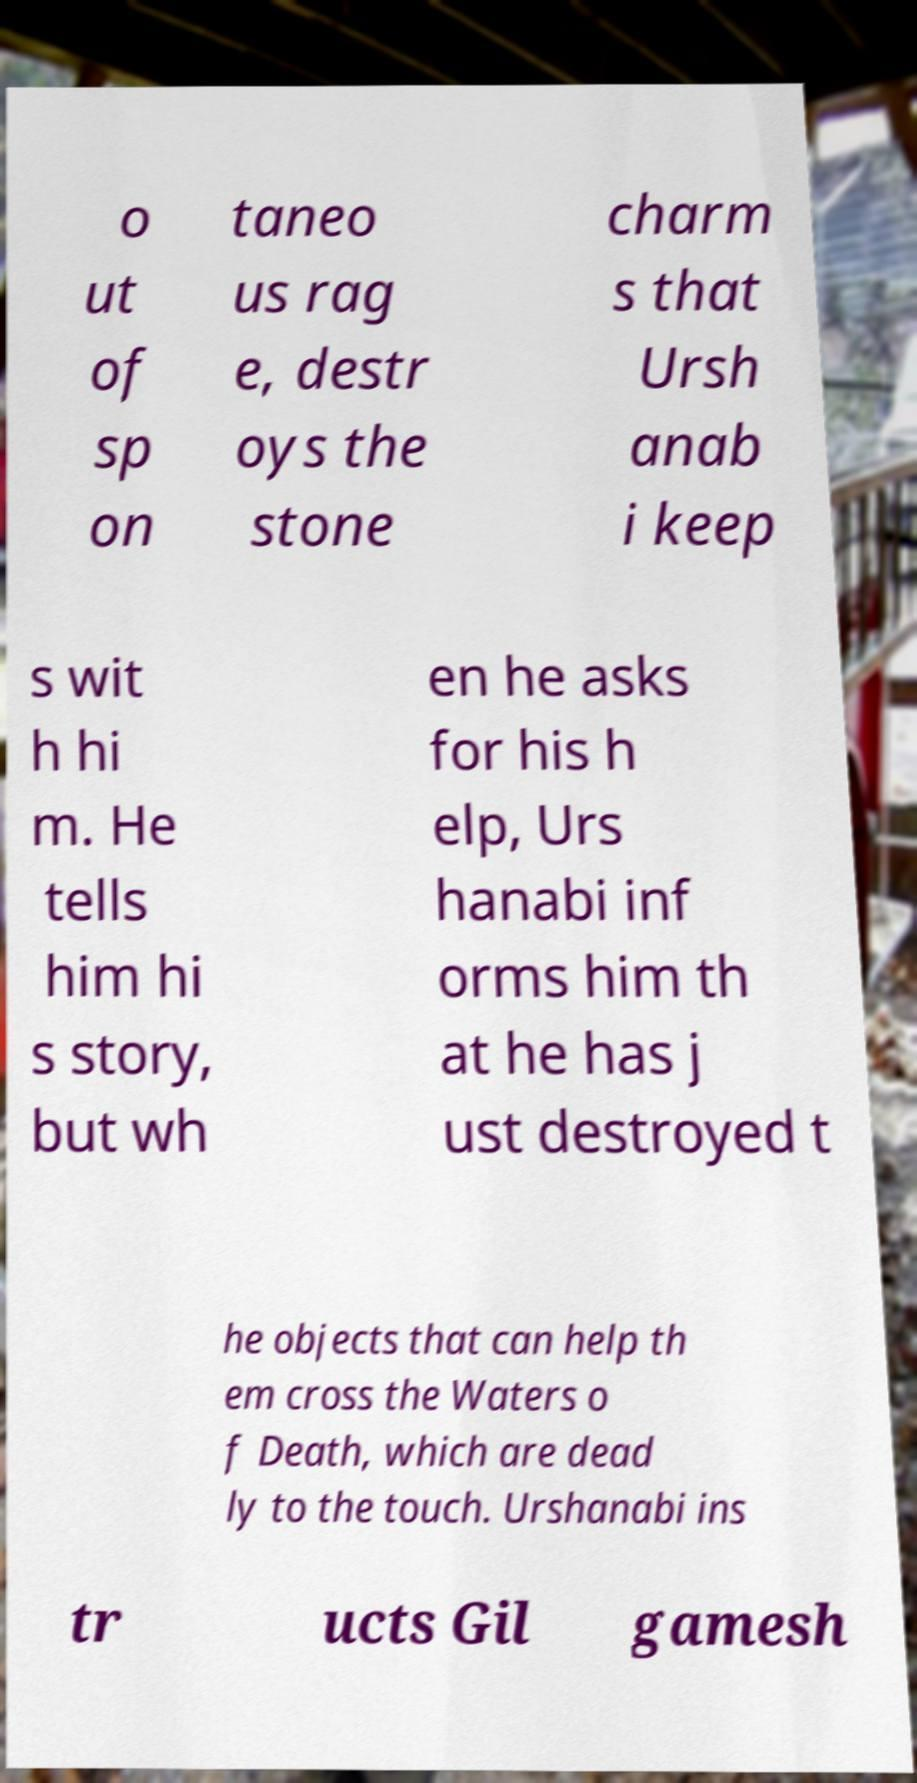Could you assist in decoding the text presented in this image and type it out clearly? o ut of sp on taneo us rag e, destr oys the stone charm s that Ursh anab i keep s wit h hi m. He tells him hi s story, but wh en he asks for his h elp, Urs hanabi inf orms him th at he has j ust destroyed t he objects that can help th em cross the Waters o f Death, which are dead ly to the touch. Urshanabi ins tr ucts Gil gamesh 